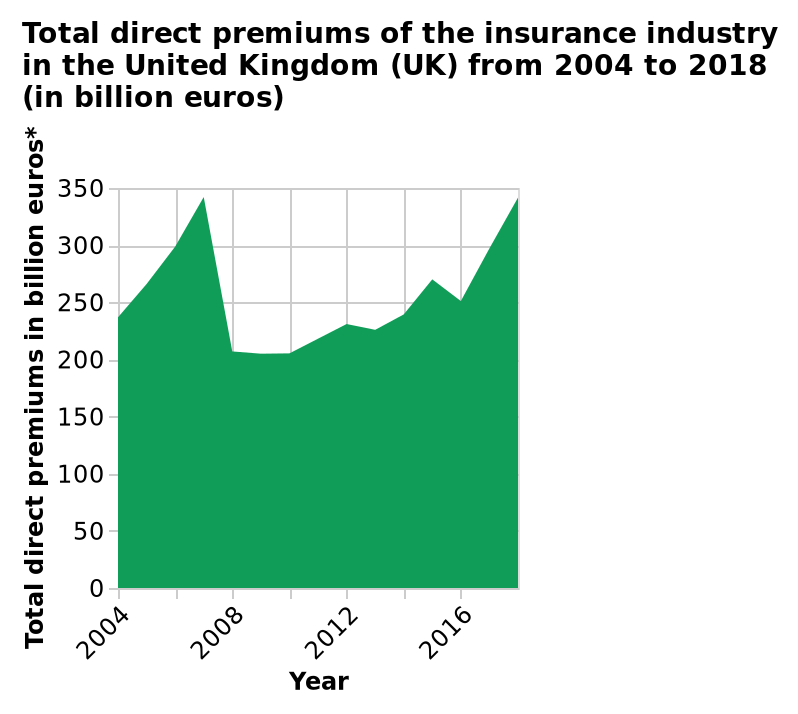<image>
Can you describe the trend in 2008? In 2008, there was a significant decrease in the trend followed by an upward movement. Offer a thorough analysis of the image. Premiums rose in the three years from 2004 to a peak of around 340 billion Euros in 2007. They then fell sharply to just above 200 billion Euros in 2008. After that there was a generally steady growth back to around 340 billion Euros in 2018. please summary the statistics and relations of the chart The overall trend appears to be upwards but with a big dip in 2008. When did the big dip occur? The big dip occurred in 2008. In what currency are the total direct premiums measured? The total direct premiums are measured in billion euros. 